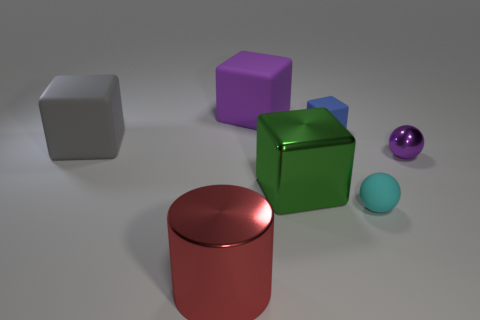Subtract all big blocks. How many blocks are left? 1 Add 2 purple objects. How many objects exist? 9 Subtract all purple spheres. How many spheres are left? 1 Subtract all spheres. How many objects are left? 5 Subtract 3 cubes. How many cubes are left? 1 Subtract all gray cylinders. Subtract all green spheres. How many cylinders are left? 1 Subtract all rubber blocks. Subtract all large green matte balls. How many objects are left? 4 Add 7 small cyan matte objects. How many small cyan matte objects are left? 8 Add 4 large gray metal objects. How many large gray metal objects exist? 4 Subtract 1 red cylinders. How many objects are left? 6 